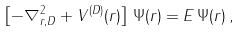Convert formula to latex. <formula><loc_0><loc_0><loc_500><loc_500>\left [ - \nabla _ { { r } , { D } } ^ { 2 } + V ^ { ( { D } ) } ( { r } ) \right ] \, \Psi ( { r } ) = E \, \Psi ( { r } ) \, ,</formula> 